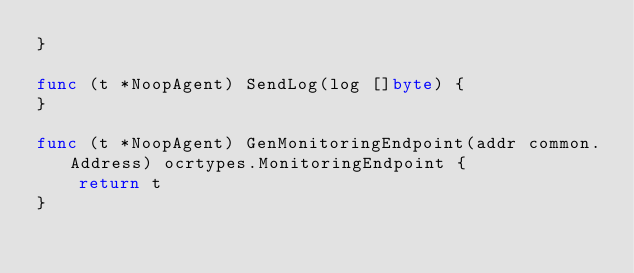<code> <loc_0><loc_0><loc_500><loc_500><_Go_>}

func (t *NoopAgent) SendLog(log []byte) {
}

func (t *NoopAgent) GenMonitoringEndpoint(addr common.Address) ocrtypes.MonitoringEndpoint {
	return t
}
</code> 